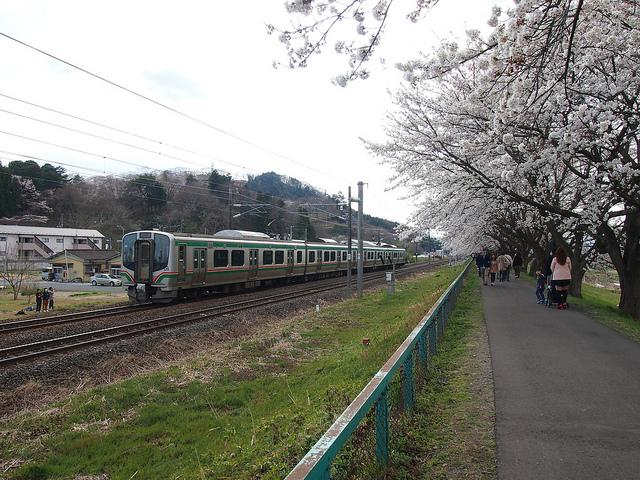What type of socks is the woman pushing the stroller wearing? Please explain your reasoning. knee-high. The socks are knee high. 